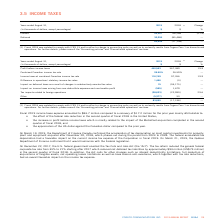According to Cogeco's financial document, What were the income tax expense in 2019? According to the financial document, $83.7 (in millions). The relevant text states: "Fiscal 2019 income taxes expense amounted to $83.7 million compared to a recovery of $17.2 million for the prior year mainly attributable to:..." Also, What was the income tax recovery in 2019? According to the financial document, $17.2 (in millions). The relevant text states: "mounted to $83.7 million compared to a recovery of $17.2 million for the prior year mainly attributable to:..." Also, When did  the Department of Finance Canada confirmed the acceleration of tax depreciation on most capital investments for property, plant and equipment acquired after November 20, 2018? According to the financial document, March 19, 2019. The relevant text states: "On March 19, 2019, the Department of Finance Canada confirmed the acceleration of tax depreciation on most capital in..." Also, can you calculate: What was the increase / (decrease) in the Profit before income taxes from 2018 to 2019? Based on the calculation: 440,563 - 367,380, the result is 73183 (in thousands). This is based on the information: "Profit before income taxes 440,563 367,380 19.9 Profit before income taxes 440,563 367,380 19.9..." The key data points involved are: 367,380, 440,563. Also, can you calculate: What was the average Income taxes at combined Canadian income tax rate? To answer this question, I need to perform calculations using the financial data. The calculation is: (116,749 + 97,356) / 2, which equals 107052.5 (in thousands). This is based on the information: "Income taxes at combined Canadian income tax rate 116,749 97,356 19.9 axes at combined Canadian income tax rate 116,749 97,356 19.9..." The key data points involved are: 116,749, 97,356. Also, can you calculate: What was the average Tax impacts related to foreign operations between 2018 and 2019? To answer this question, I need to perform calculations using the financial data. The calculation is: - (28,633 + 22,099) / 2, which equals -25366 (in thousands). This is based on the information: "Tax impacts related to foreign operations (28,633) (22,099) 29.6 x impacts related to foreign operations (28,633) (22,099) 29.6..." The key data points involved are: 22,099, 28,633. 